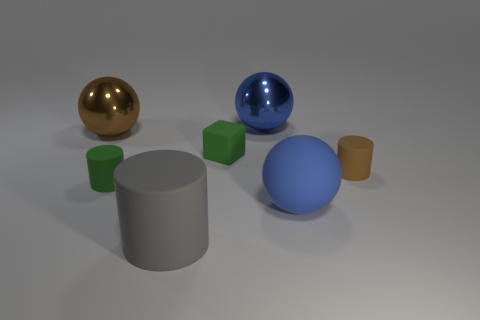Subtract all blue spheres. How many were subtracted if there are1blue spheres left? 1 Add 1 cyan rubber things. How many objects exist? 8 Subtract all spheres. How many objects are left? 4 Subtract 1 brown cylinders. How many objects are left? 6 Subtract all small brown cylinders. Subtract all green objects. How many objects are left? 4 Add 5 big metal things. How many big metal things are left? 7 Add 1 tiny green matte objects. How many tiny green matte objects exist? 3 